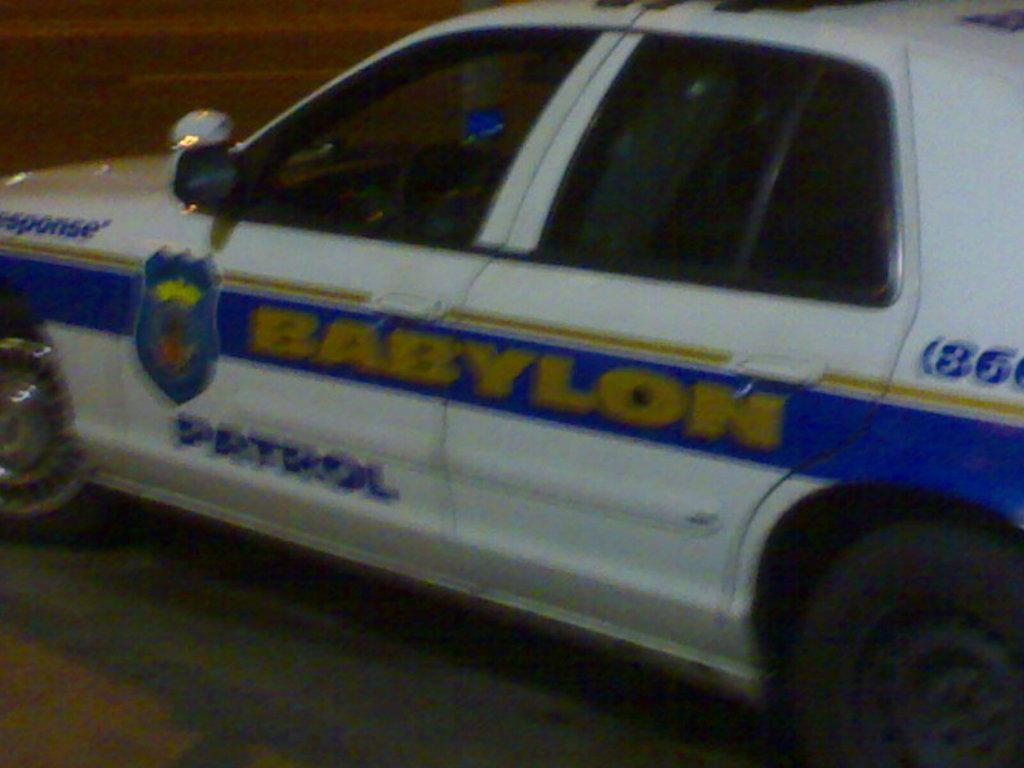<image>
Share a concise interpretation of the image provided. A police car that says Babylon patrol on the side. 